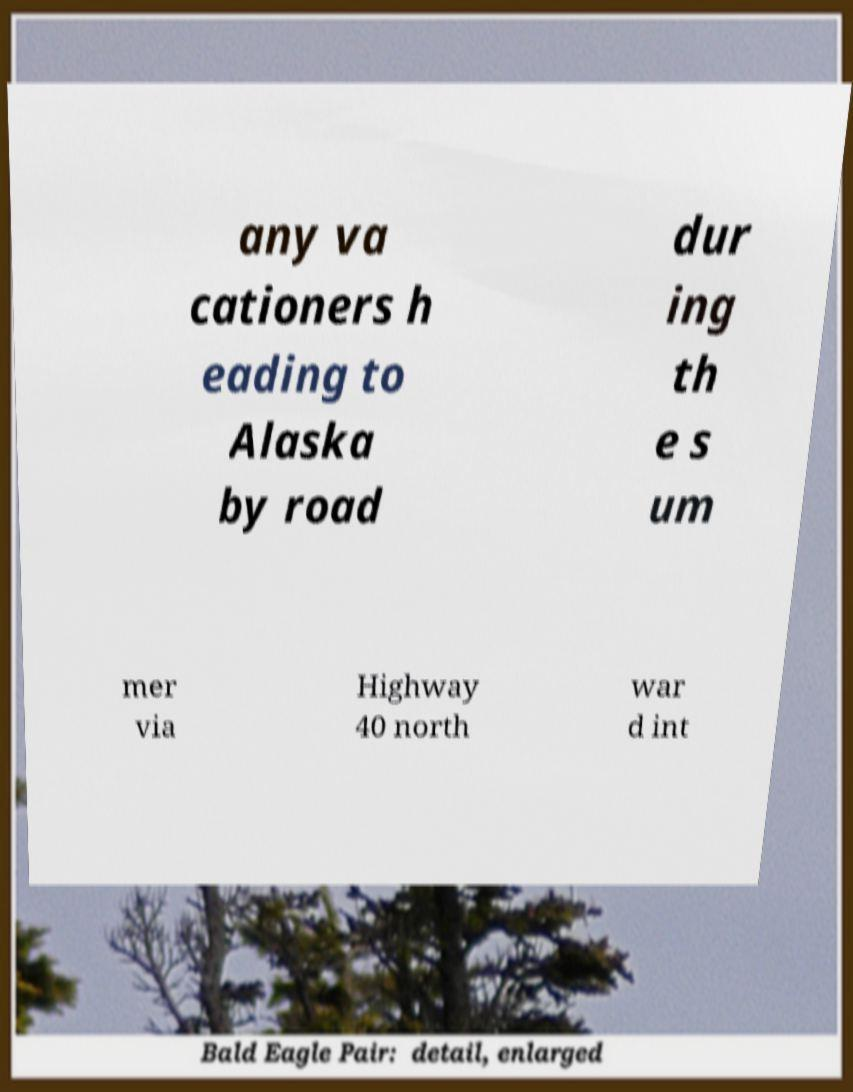Please read and relay the text visible in this image. What does it say? any va cationers h eading to Alaska by road dur ing th e s um mer via Highway 40 north war d int 